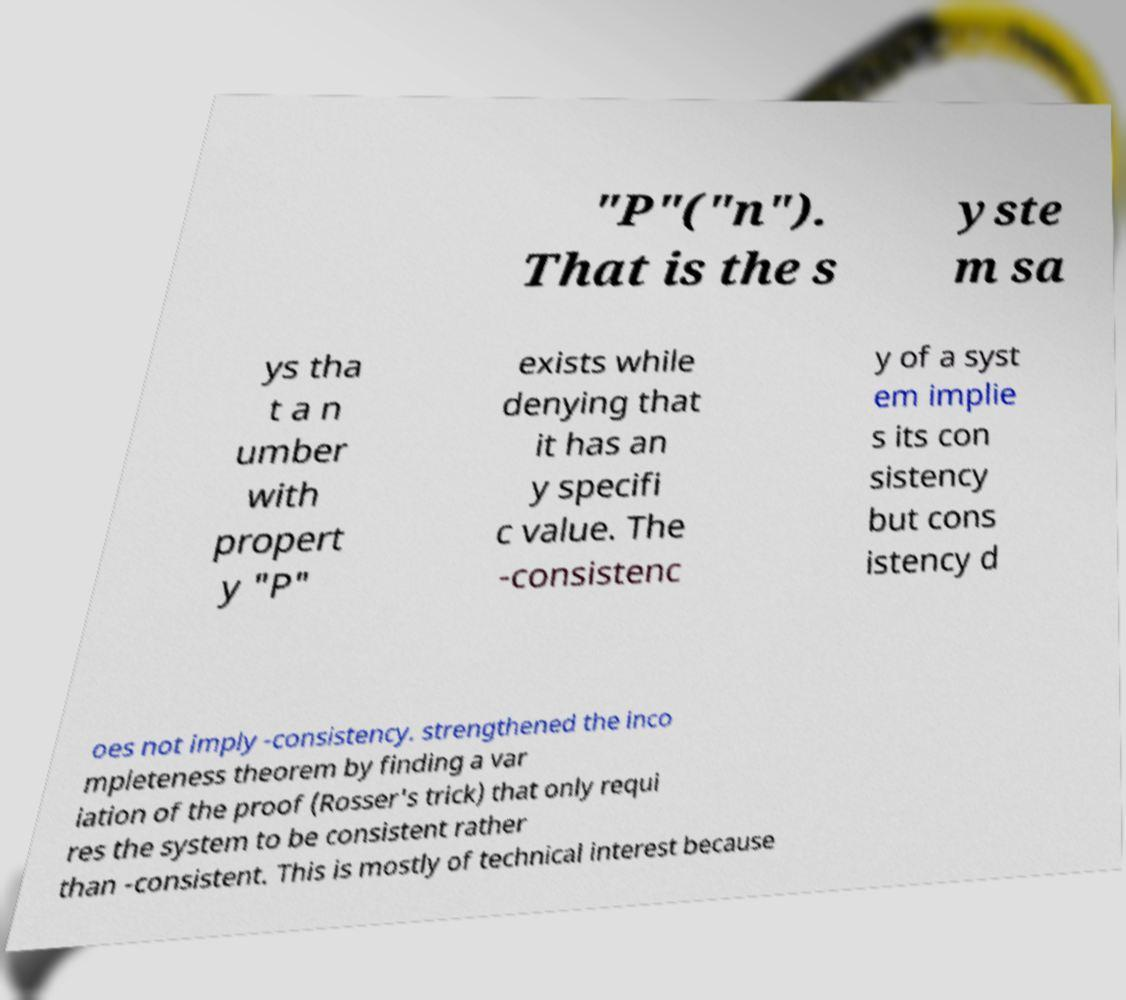Could you assist in decoding the text presented in this image and type it out clearly? "P"("n"). That is the s yste m sa ys tha t a n umber with propert y "P" exists while denying that it has an y specifi c value. The -consistenc y of a syst em implie s its con sistency but cons istency d oes not imply -consistency. strengthened the inco mpleteness theorem by finding a var iation of the proof (Rosser's trick) that only requi res the system to be consistent rather than -consistent. This is mostly of technical interest because 